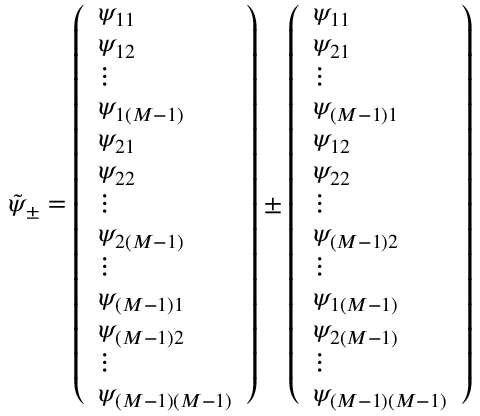<formula> <loc_0><loc_0><loc_500><loc_500>\tilde { \psi } _ { \pm } = \left ( \begin{array} { l } { \psi _ { 1 1 } } \\ { \psi _ { 1 2 } } \\ { \vdots } \\ { \psi _ { 1 \left ( M - 1 \right ) } } \\ { \psi _ { 2 1 } } \\ { \psi _ { 2 2 } } \\ { \vdots } \\ { \psi _ { 2 \left ( M - 1 \right ) } } \\ { \vdots } \\ { \psi _ { \left ( M - 1 \right ) 1 } } \\ { \psi _ { \left ( M - 1 \right ) 2 } } \\ { \vdots } \\ { \psi _ { \left ( M - 1 \right ) \left ( M - 1 \right ) } } \end{array} \right ) \pm \left ( \begin{array} { l } { \psi _ { 1 1 } } \\ { \psi _ { 2 1 } } \\ { \vdots } \\ { \psi _ { \left ( M - 1 \right ) 1 } } \\ { \psi _ { 1 2 } } \\ { \psi _ { 2 2 } } \\ { \vdots } \\ { \psi _ { \left ( M - 1 \right ) 2 } } \\ { \vdots } \\ { \psi _ { 1 \left ( M - 1 \right ) } } \\ { \psi _ { 2 \left ( M - 1 \right ) } } \\ { \vdots } \\ { \psi _ { \left ( M - 1 \right ) \left ( M - 1 \right ) } } \end{array} \right )</formula> 